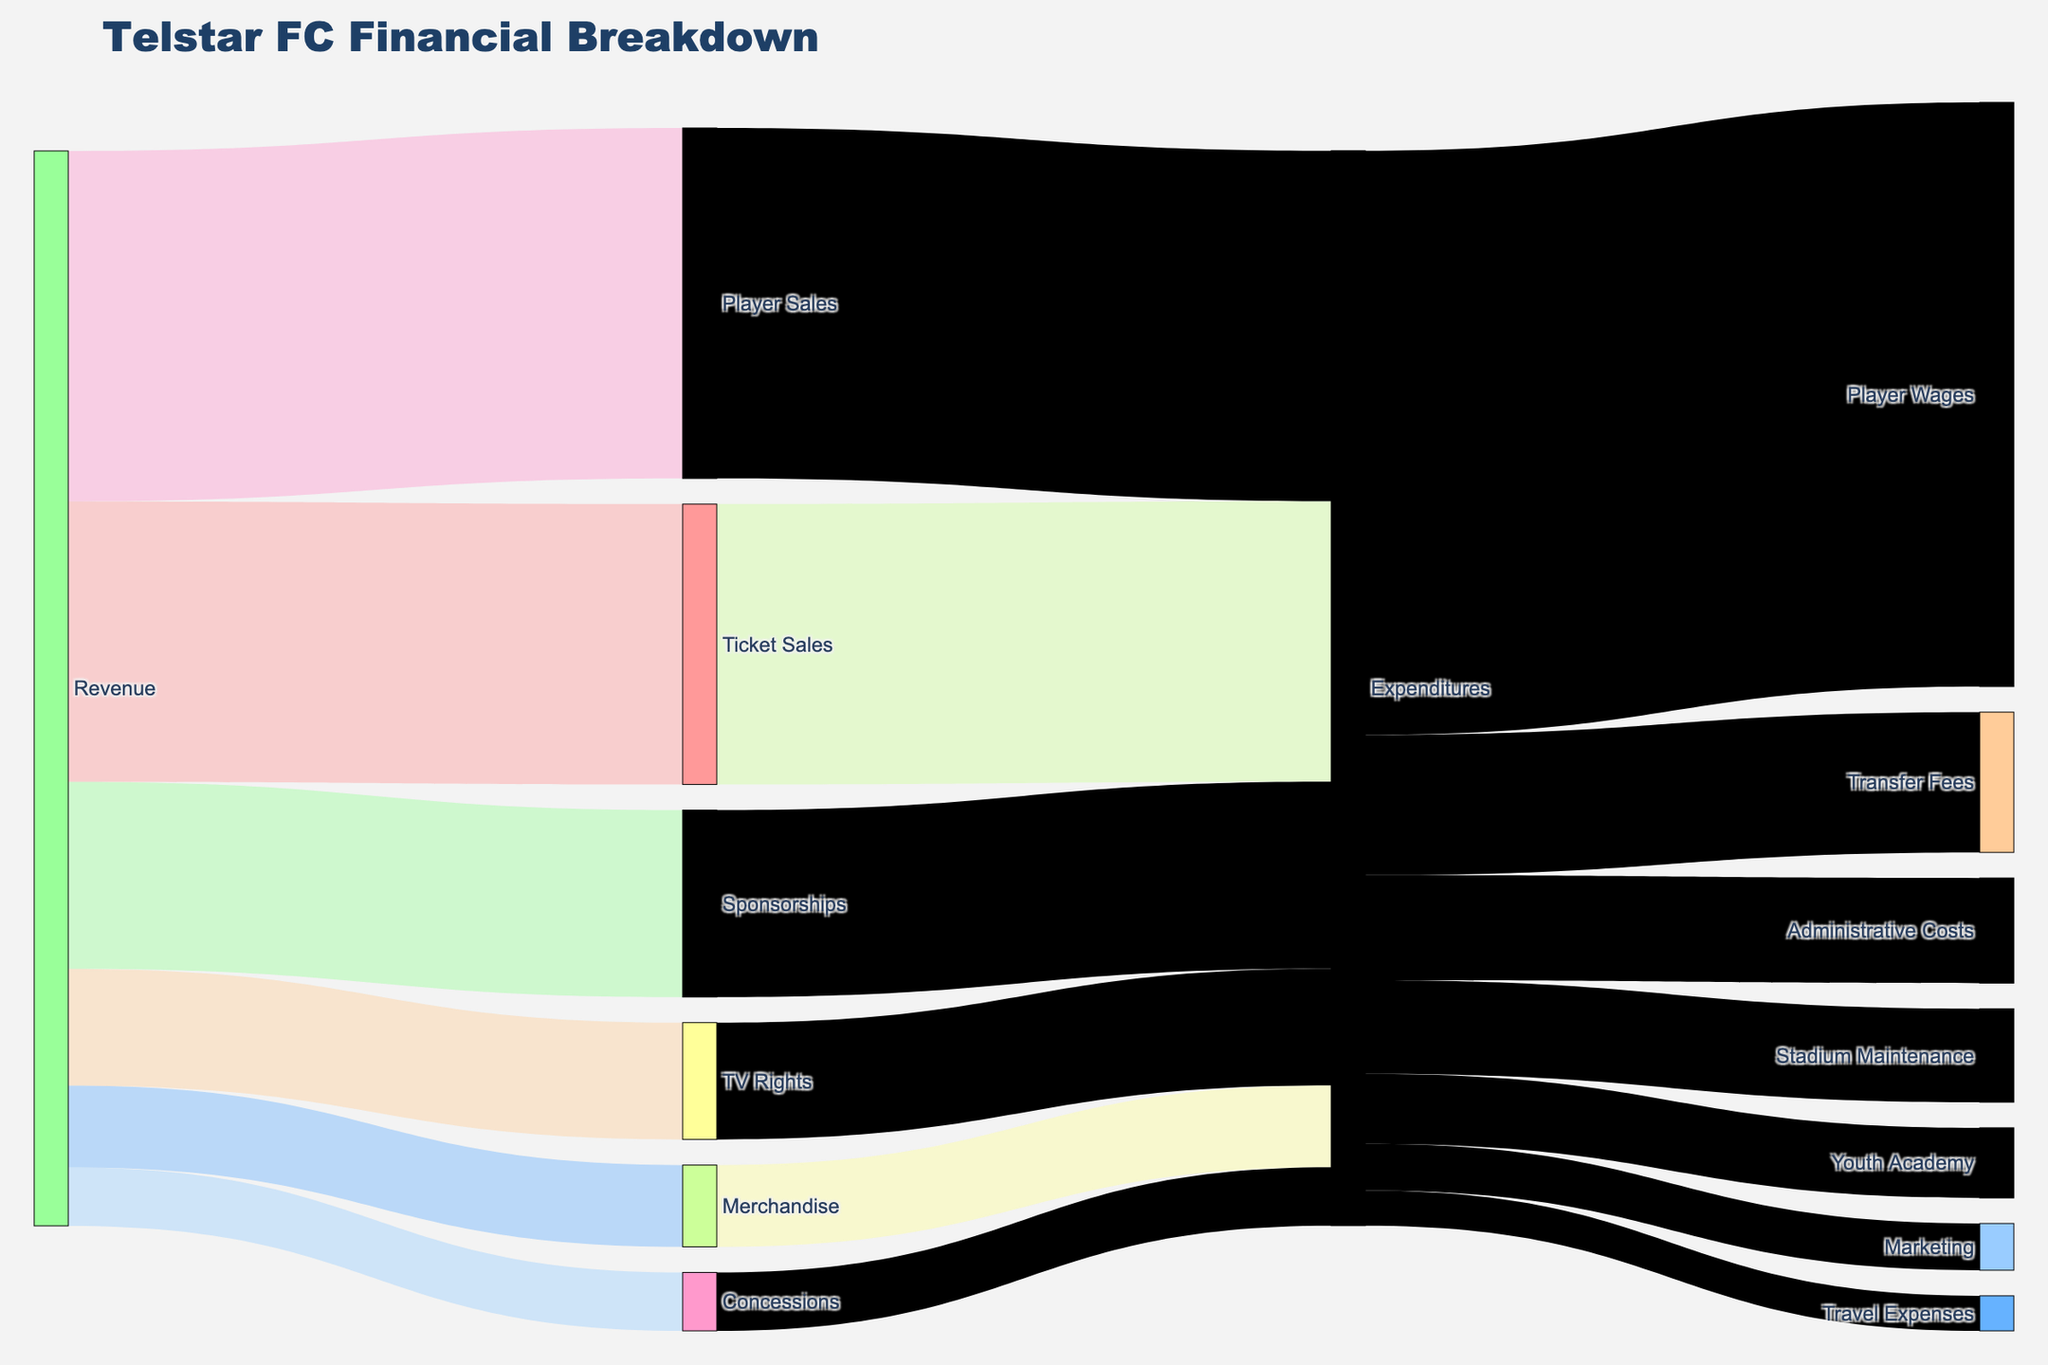What's the total revenue generated by Telstar in a season? To find the total revenue, add up all the revenue streams: Ticket Sales, Merchandise, Sponsorships, TV Rights, Player Sales, and Concessions. \(1,200,000 + 350,000 + 800,000 + 500,000 + 1,500,000 + 250,000 = 4,600,000\)
Answer: 4,600,000 What is the largest expenditure category for Telstar? By comparing the values of all expenditure categories, it becomes apparent that Player Wages has the highest value of \(2,500,000\).
Answer: Player Wages How does the revenue from TV Rights compare to the revenue from Merchandise? The revenue from TV Rights is \(500,000\) while the revenue from Merchandise is \(350,000\). \(500,000\) is greater than \(350,000\).
Answer: TV Rights is greater What is the total expenditure on both Stadium Maintenance and Youth Academy? Add the expenditures for Stadium Maintenance and Youth Academy. \(400,000 + 300,000 = 700,000\).
Answer: 700,000 What's the net income (total revenue minus total expenditures) for Telstar? First, calculate total expenditures: \(2,500,000 + 400,000 + 300,000 + 600,000 + 450,000 + 200,000 + 150,000 = 4,600,000\). Since total revenue is also \(4,600,000\), the net income is \(4,600,000 - 4,600,000 = 0\).
Answer: 0 Which revenue stream contributes the least to Telstar’s total revenue? By examining all revenue streams, Concessions contribute \(250,000\), which is the smallest amount compared to others.
Answer: Concessions What's the percentage of total revenue that comes from Player Sales? Divide Player Sales revenue by total revenue and multiply by 100: \(\left(\frac{1,500,000}{4,600,000}\right) \times 100 \approx 32.61\%\).
Answer: ≈32.61% How many categories of expenditure are shown in the Sankey Diagram? Listing all the unique expenditure categories: Player Wages, Stadium Maintenance, Youth Academy, Transfer Fees, Administrative Costs, Marketing, Travel Expenses gives a total of 7 categories.
Answer: 7 